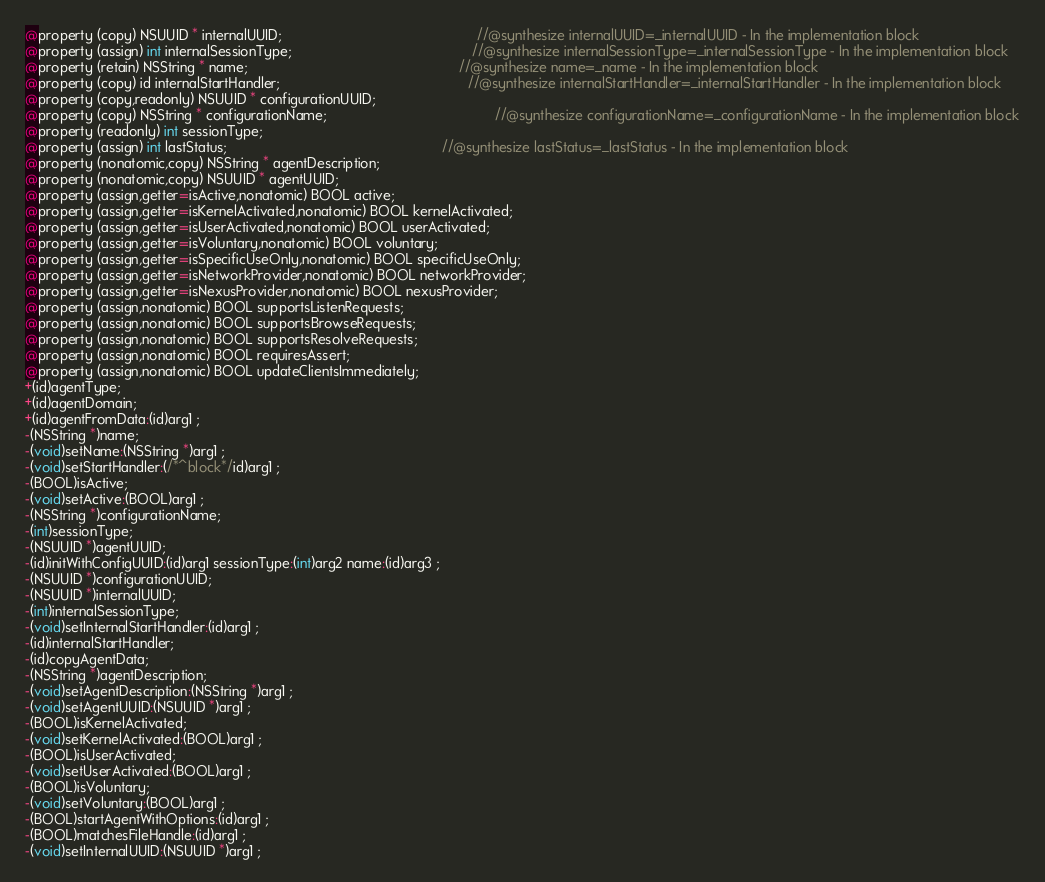Convert code to text. <code><loc_0><loc_0><loc_500><loc_500><_C_>@property (copy) NSUUID * internalUUID;                                                  //@synthesize internalUUID=_internalUUID - In the implementation block
@property (assign) int internalSessionType;                                              //@synthesize internalSessionType=_internalSessionType - In the implementation block
@property (retain) NSString * name;                                                      //@synthesize name=_name - In the implementation block
@property (copy) id internalStartHandler;                                                //@synthesize internalStartHandler=_internalStartHandler - In the implementation block
@property (copy,readonly) NSUUID * configurationUUID; 
@property (copy) NSString * configurationName;                                           //@synthesize configurationName=_configurationName - In the implementation block
@property (readonly) int sessionType; 
@property (assign) int lastStatus;                                                       //@synthesize lastStatus=_lastStatus - In the implementation block
@property (nonatomic,copy) NSString * agentDescription; 
@property (nonatomic,copy) NSUUID * agentUUID; 
@property (assign,getter=isActive,nonatomic) BOOL active; 
@property (assign,getter=isKernelActivated,nonatomic) BOOL kernelActivated; 
@property (assign,getter=isUserActivated,nonatomic) BOOL userActivated; 
@property (assign,getter=isVoluntary,nonatomic) BOOL voluntary; 
@property (assign,getter=isSpecificUseOnly,nonatomic) BOOL specificUseOnly; 
@property (assign,getter=isNetworkProvider,nonatomic) BOOL networkProvider; 
@property (assign,getter=isNexusProvider,nonatomic) BOOL nexusProvider; 
@property (assign,nonatomic) BOOL supportsListenRequests; 
@property (assign,nonatomic) BOOL supportsBrowseRequests; 
@property (assign,nonatomic) BOOL supportsResolveRequests; 
@property (assign,nonatomic) BOOL requiresAssert; 
@property (assign,nonatomic) BOOL updateClientsImmediately; 
+(id)agentType;
+(id)agentDomain;
+(id)agentFromData:(id)arg1 ;
-(NSString *)name;
-(void)setName:(NSString *)arg1 ;
-(void)setStartHandler:(/*^block*/id)arg1 ;
-(BOOL)isActive;
-(void)setActive:(BOOL)arg1 ;
-(NSString *)configurationName;
-(int)sessionType;
-(NSUUID *)agentUUID;
-(id)initWithConfigUUID:(id)arg1 sessionType:(int)arg2 name:(id)arg3 ;
-(NSUUID *)configurationUUID;
-(NSUUID *)internalUUID;
-(int)internalSessionType;
-(void)setInternalStartHandler:(id)arg1 ;
-(id)internalStartHandler;
-(id)copyAgentData;
-(NSString *)agentDescription;
-(void)setAgentDescription:(NSString *)arg1 ;
-(void)setAgentUUID:(NSUUID *)arg1 ;
-(BOOL)isKernelActivated;
-(void)setKernelActivated:(BOOL)arg1 ;
-(BOOL)isUserActivated;
-(void)setUserActivated:(BOOL)arg1 ;
-(BOOL)isVoluntary;
-(void)setVoluntary:(BOOL)arg1 ;
-(BOOL)startAgentWithOptions:(id)arg1 ;
-(BOOL)matchesFileHandle:(id)arg1 ;
-(void)setInternalUUID:(NSUUID *)arg1 ;</code> 